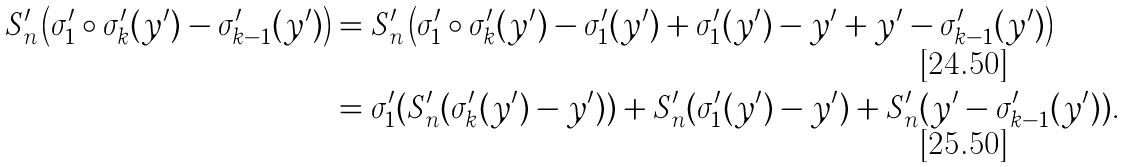<formula> <loc_0><loc_0><loc_500><loc_500>S _ { n } ^ { \prime } \left ( \sigma ^ { \prime } _ { 1 } \circ \sigma ^ { \prime } _ { k } ( y ^ { \prime } ) - \sigma _ { k - 1 } ^ { \prime } ( y ^ { \prime } ) \right ) & = S _ { n } ^ { \prime } \left ( \sigma ^ { \prime } _ { 1 } \circ \sigma ^ { \prime } _ { k } ( y ^ { \prime } ) - \sigma ^ { \prime } _ { 1 } ( y ^ { \prime } ) + \sigma ^ { \prime } _ { 1 } ( y ^ { \prime } ) - y ^ { \prime } + y ^ { \prime } - \sigma _ { k - 1 } ^ { \prime } ( y ^ { \prime } ) \right ) \\ & = \sigma ^ { \prime } _ { 1 } ( S _ { n } ^ { \prime } ( \sigma ^ { \prime } _ { k } ( y ^ { \prime } ) - y ^ { \prime } ) ) + S _ { n } ^ { \prime } ( \sigma ^ { \prime } _ { 1 } ( y ^ { \prime } ) - y ^ { \prime } ) + S _ { n } ^ { \prime } ( y ^ { \prime } - \sigma _ { k - 1 } ^ { \prime } ( y ^ { \prime } ) ) .</formula> 